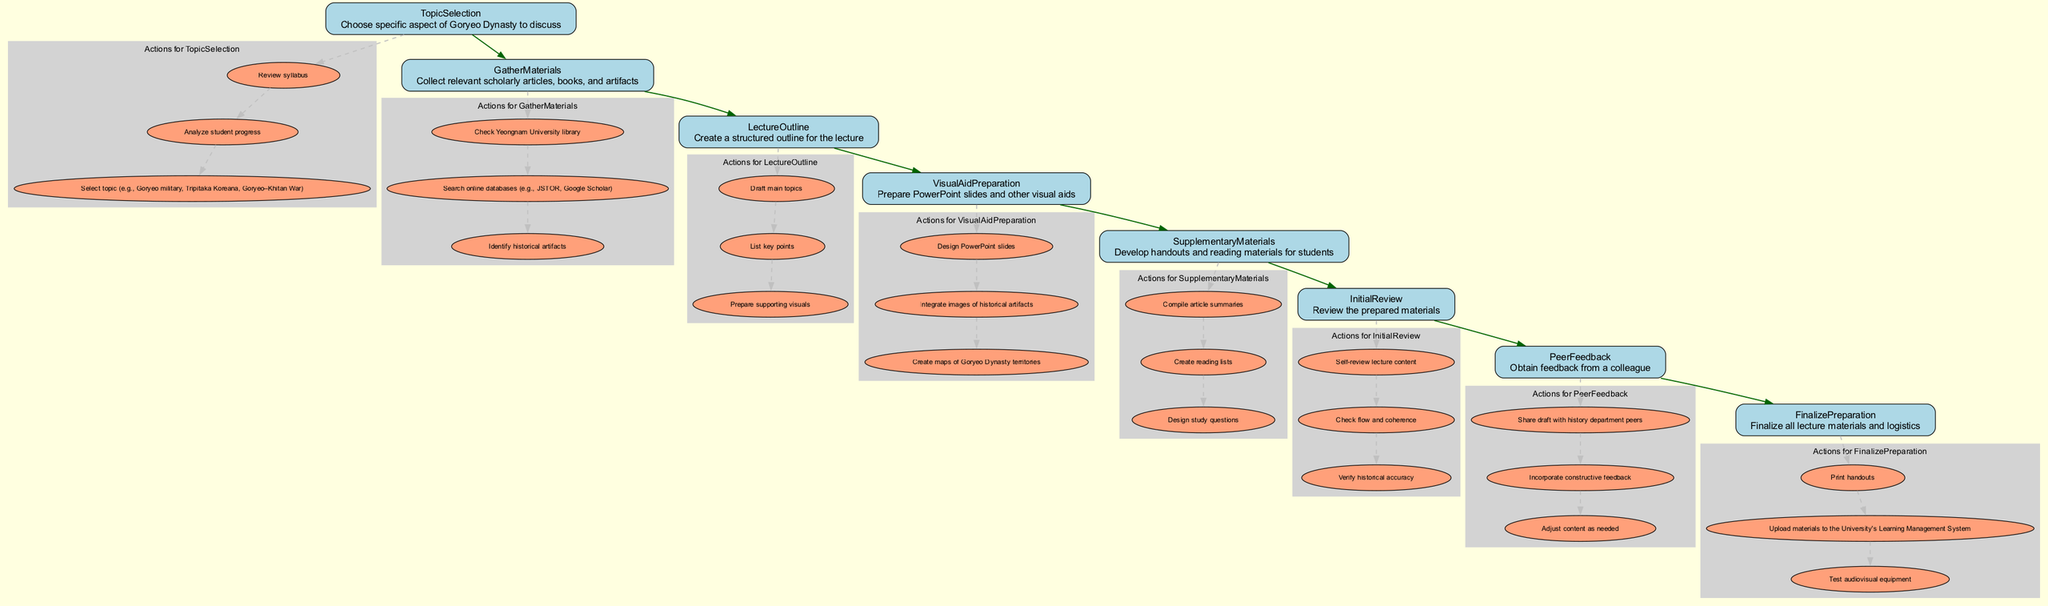What is the first step in the Class Preparation Workflow? The first step is TopicSelection, which sets the foundation for the preparation process. This node is located at the top of the flowchart and serves as the starting point.
Answer: TopicSelection How many main elements are there in the workflow? The workflow contains eight main elements, each representing a stage of the preparation process, from TopicSelection to FinalizePreparation.
Answer: Eight Which element involves collecting scholarly articles? The element that involves collecting scholarly articles is GatherMaterials. This node specifically focuses on the collection of relevant academic resources needed for the lecture.
Answer: GatherMaterials What action follows the LectureOutline step? The action that follows the LectureOutline step is VisualAidPreparation. After outlining the lecture, the next logical step is to create visual aids to support the content being presented.
Answer: VisualAidPreparation What type of feedback is received in the PeerFeedback step? The PeerFeedback step involves obtaining constructive feedback from a colleague. This ensures the lecture materials are reviewed by another professional for accuracy and clarity.
Answer: Constructive feedback Which node includes preparing supporting visuals? Preparing supporting visuals is part of the LectureOutline element. This is indicated in the actions listed under this node, which emphasizes structuring the lecture effectively.
Answer: LectureOutline How does the GatherMaterials step relate to the TopicSelection step? The GatherMaterials step is sequentially dependent on the TopicSelection step, as selecting the topic dictates the specific materials that need to be collected for the lecture.
Answer: Sequentially dependent What does the FinalizePreparation step ensure? The FinalizePreparation step ensures that all lecture materials are finalized and logistics are sorted, which includes actions like printing handouts and testing audiovisual equipment.
Answer: All lecture materials are finalized In how many stages is feedback incorporated during the workflow? Feedback is incorporated at one stage in the workflow, specifically during the PeerFeedback element, where drafts are shared and constructive feedback is requested.
Answer: One stage 